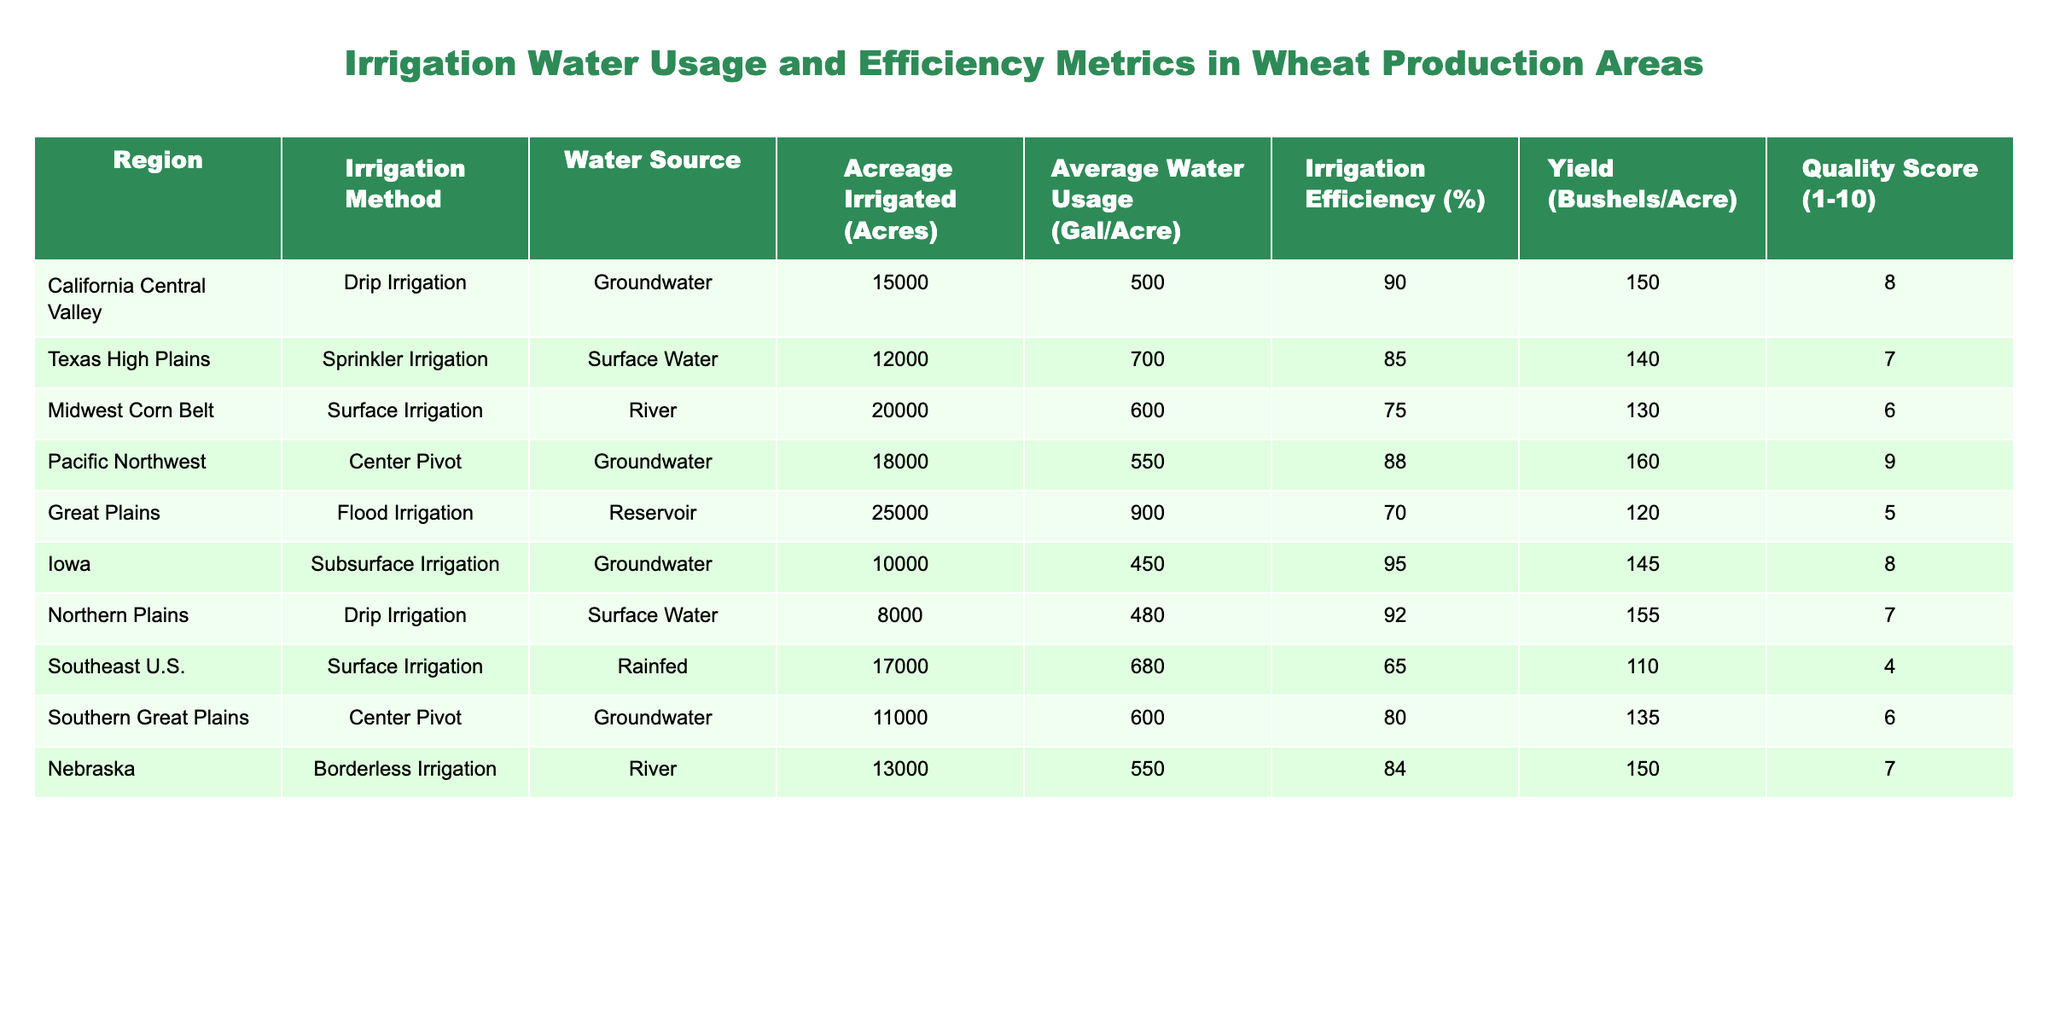What is the average irrigation efficiency across all regions? To find the average irrigation efficiency, sum the efficiency values from the table: 90 + 85 + 75 + 88 + 70 + 95 + 92 + 65 + 80 + 84 =  834. Then, divide by the number of regions, which is 10. So, the average efficiency is 834 / 10 = 83.4%
Answer: 83.4% Which region has the highest quality score? The quality scores from the table are as follows: California Central Valley (8), Texas High Plains (7), Midwest Corn Belt (6), Pacific Northwest (9), Great Plains (5), Iowa (8), Northern Plains (7), Southeast U.S. (4), Southern Great Plains (6), Nebraska (7). Among these, the Pacific Northwest has the highest score of 9.
Answer: Pacific Northwest Is the irrigation efficiency in the Great Plains region higher than that in the Midwest Corn Belt? The irrigation efficiency for Great Plains is 70%, while for Midwest Corn Belt it is 75%. Since 70% is less than 75%, the efficiency in the Great Plains is not higher than that in the Midwest Corn Belt.
Answer: No What is the total acreage irrigated in regions using groundwater as a water source? The regions using groundwater are California Central Valley (15000 acres), Pacific Northwest (18000 acres), Iowa (10000 acres), and Southern Great Plains (11000 acres). Adding these together gives: 15000 + 18000 + 10000 + 11000 = 54000 acres.
Answer: 54000 acres Does the Texas High Plains region have a higher average water usage than the Iowa region? The average water usage in Texas High Plains is 700 gallons per acre, while in Iowa it is 450 gallons per acre. Since 700 is greater than 450, Texas High Plains indeed has a higher water usage.
Answer: Yes What is the yield difference between regions using surface water and those using groundwater? Surface water regions are Texas High Plains (140), Midwest Corn Belt (130), Southeast U.S. (110), and Nebraska (150), averaging 132.5 bushels per acre. Groundwater regions are California Central Valley (150), Pacific Northwest (160), Iowa (145), and Southern Great Plains (135), averaging 147.5 bushels per acre. The yield difference is 147.5 - 132.5 = 15 bushels per acre.
Answer: 15 bushels per acre Which irrigation method has the lowest average yield? The irrigation methods and their corresponding yields are: Drip Irrigation (California Central Valley 150, Northern Plains 155), Sprinkler Irrigation (Texas High Plains 140), Surface Irrigation (Midwest Corn Belt 130, Southeast U.S. 110), Center Pivot (Pacific Northwest 160, Southern Great Plains 135), and Flood Irrigation (Great Plains 120). The lowest yield is with Surface Irrigation in Southeast U.S. at 110 bushels per acre.
Answer: Surface Irrigation What percentage of irrigation efficiency is above 80%? Reviewing the irrigation efficiency figures: 90, 85, 75, 88, 70, 95, 92, 65, 80, 84 — six of these values (90, 85, 88, 95, 92, 84) are above 80%. Since there are 10 total values, the percentage is (6/10) * 100 = 60%.
Answer: 60% 